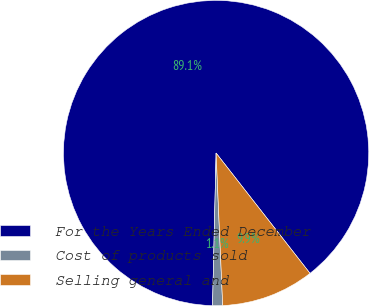Convert chart. <chart><loc_0><loc_0><loc_500><loc_500><pie_chart><fcel>For the Years Ended December<fcel>Cost of products sold<fcel>Selling general and<nl><fcel>89.07%<fcel>1.06%<fcel>9.86%<nl></chart> 